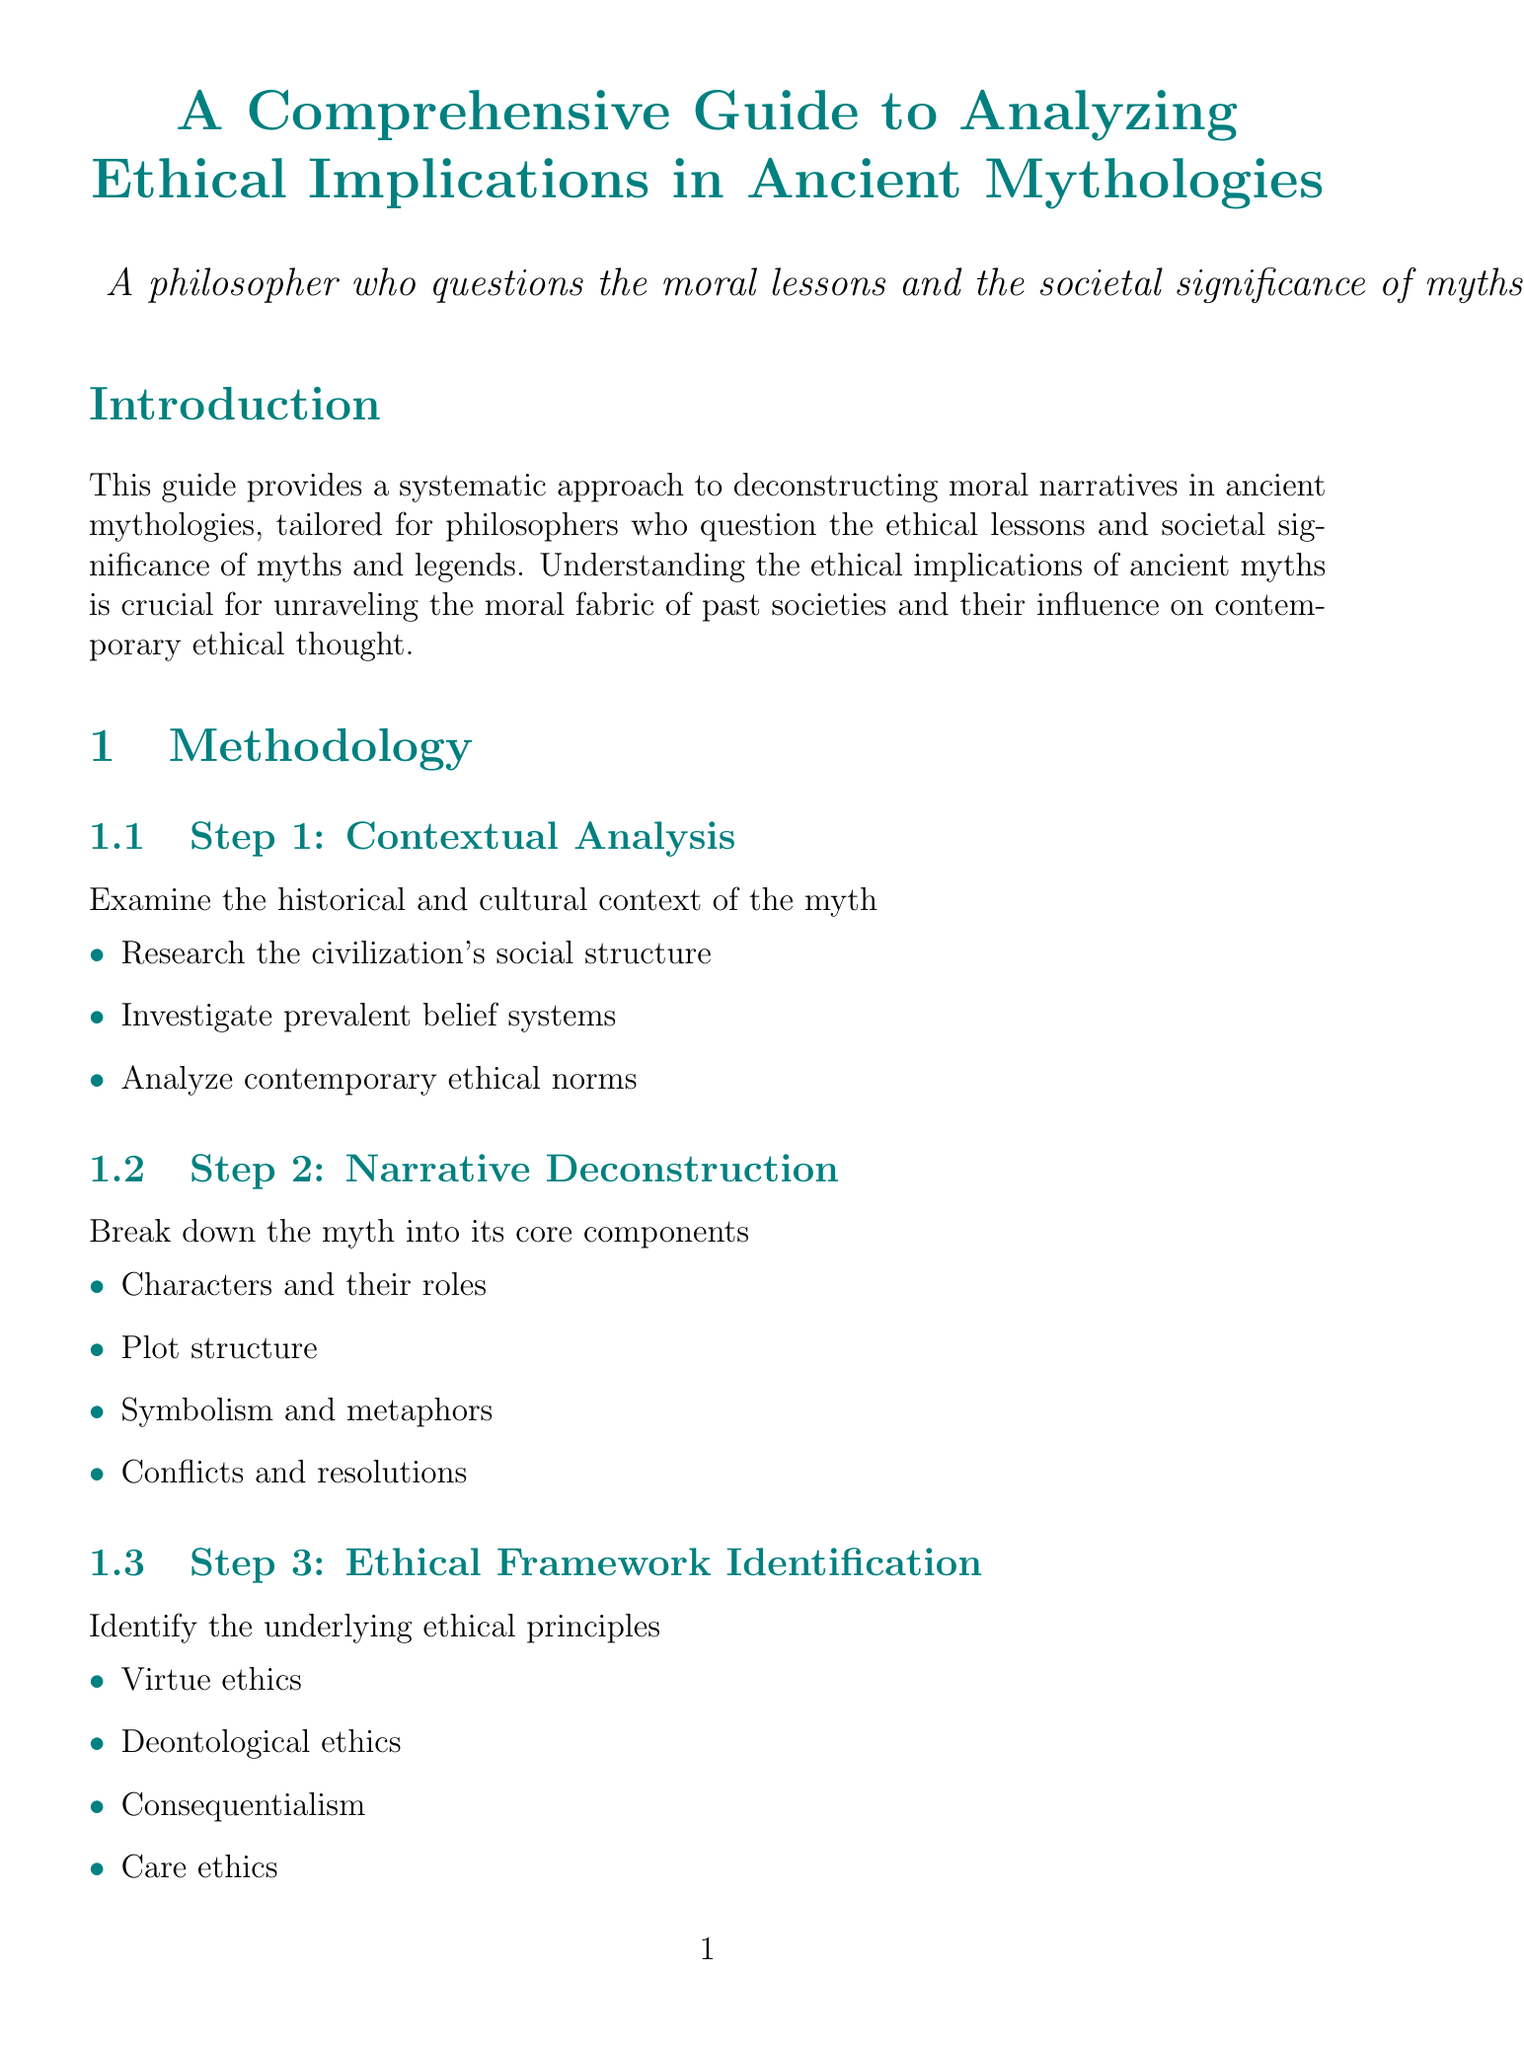What is the title of the guide? The title is clearly stated at the beginning of the document.
Answer: A Comprehensive Guide to Analyzing Ethical Implications in Ancient Mythologies How many steps are there in the methodology? The methodology section lists seven distinct steps for analysis.
Answer: 7 Name one ethical framework identified in the guide. The document lists various ethical frameworks under Step 3.
Answer: Virtue ethics What is one ethical theme from Greek mythology? The case studies section identifies ethical themes related to specific myths.
Answer: Rebellion against authority Which philosophical perspective examines the universalizability of moral lessons? The philosophical perspectives section provides details on various approaches.
Answer: Kantian Ethics What is a challenge mentioned in the guide? The challenges and considerations section outlines various difficulties in interpreting myths.
Answer: Cultural relativism and ethical interpretation What is the focus of Step 6 in the methodology? Step 6 clearly states its purpose regarding ethical implications.
Answer: Comparative Analysis 